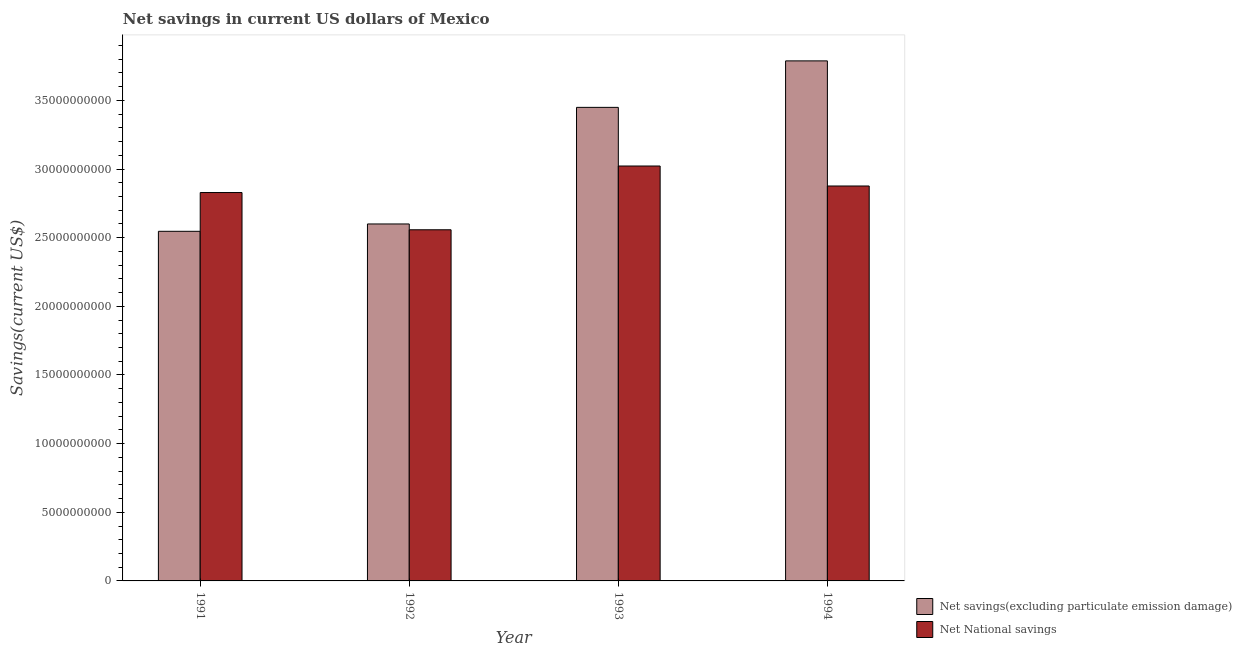How many different coloured bars are there?
Keep it short and to the point. 2. How many groups of bars are there?
Your response must be concise. 4. Are the number of bars per tick equal to the number of legend labels?
Ensure brevity in your answer.  Yes. Are the number of bars on each tick of the X-axis equal?
Ensure brevity in your answer.  Yes. How many bars are there on the 1st tick from the right?
Your answer should be very brief. 2. What is the label of the 2nd group of bars from the left?
Offer a very short reply. 1992. What is the net national savings in 1993?
Ensure brevity in your answer.  3.02e+1. Across all years, what is the maximum net national savings?
Give a very brief answer. 3.02e+1. Across all years, what is the minimum net national savings?
Offer a terse response. 2.56e+1. In which year was the net savings(excluding particulate emission damage) minimum?
Your answer should be compact. 1991. What is the total net national savings in the graph?
Keep it short and to the point. 1.13e+11. What is the difference between the net national savings in 1991 and that in 1992?
Your answer should be compact. 2.71e+09. What is the difference between the net national savings in 1991 and the net savings(excluding particulate emission damage) in 1993?
Offer a very short reply. -1.93e+09. What is the average net savings(excluding particulate emission damage) per year?
Your response must be concise. 3.10e+1. What is the ratio of the net national savings in 1992 to that in 1994?
Provide a succinct answer. 0.89. Is the net savings(excluding particulate emission damage) in 1991 less than that in 1993?
Give a very brief answer. Yes. Is the difference between the net savings(excluding particulate emission damage) in 1991 and 1993 greater than the difference between the net national savings in 1991 and 1993?
Make the answer very short. No. What is the difference between the highest and the second highest net savings(excluding particulate emission damage)?
Ensure brevity in your answer.  3.39e+09. What is the difference between the highest and the lowest net savings(excluding particulate emission damage)?
Provide a short and direct response. 1.24e+1. Is the sum of the net savings(excluding particulate emission damage) in 1991 and 1993 greater than the maximum net national savings across all years?
Keep it short and to the point. Yes. What does the 1st bar from the left in 1993 represents?
Offer a very short reply. Net savings(excluding particulate emission damage). What does the 2nd bar from the right in 1993 represents?
Ensure brevity in your answer.  Net savings(excluding particulate emission damage). What is the difference between two consecutive major ticks on the Y-axis?
Your answer should be compact. 5.00e+09. Are the values on the major ticks of Y-axis written in scientific E-notation?
Offer a terse response. No. Does the graph contain any zero values?
Provide a succinct answer. No. Does the graph contain grids?
Ensure brevity in your answer.  No. Where does the legend appear in the graph?
Provide a short and direct response. Bottom right. How are the legend labels stacked?
Keep it short and to the point. Vertical. What is the title of the graph?
Provide a succinct answer. Net savings in current US dollars of Mexico. Does "Constant 2005 US$" appear as one of the legend labels in the graph?
Your answer should be compact. No. What is the label or title of the X-axis?
Make the answer very short. Year. What is the label or title of the Y-axis?
Offer a very short reply. Savings(current US$). What is the Savings(current US$) in Net savings(excluding particulate emission damage) in 1991?
Give a very brief answer. 2.55e+1. What is the Savings(current US$) in Net National savings in 1991?
Keep it short and to the point. 2.83e+1. What is the Savings(current US$) in Net savings(excluding particulate emission damage) in 1992?
Your answer should be very brief. 2.60e+1. What is the Savings(current US$) of Net National savings in 1992?
Offer a very short reply. 2.56e+1. What is the Savings(current US$) in Net savings(excluding particulate emission damage) in 1993?
Offer a terse response. 3.45e+1. What is the Savings(current US$) in Net National savings in 1993?
Provide a succinct answer. 3.02e+1. What is the Savings(current US$) in Net savings(excluding particulate emission damage) in 1994?
Offer a very short reply. 3.79e+1. What is the Savings(current US$) of Net National savings in 1994?
Make the answer very short. 2.88e+1. Across all years, what is the maximum Savings(current US$) in Net savings(excluding particulate emission damage)?
Make the answer very short. 3.79e+1. Across all years, what is the maximum Savings(current US$) in Net National savings?
Offer a very short reply. 3.02e+1. Across all years, what is the minimum Savings(current US$) of Net savings(excluding particulate emission damage)?
Provide a short and direct response. 2.55e+1. Across all years, what is the minimum Savings(current US$) of Net National savings?
Offer a very short reply. 2.56e+1. What is the total Savings(current US$) in Net savings(excluding particulate emission damage) in the graph?
Offer a very short reply. 1.24e+11. What is the total Savings(current US$) in Net National savings in the graph?
Your answer should be very brief. 1.13e+11. What is the difference between the Savings(current US$) in Net savings(excluding particulate emission damage) in 1991 and that in 1992?
Your answer should be compact. -5.34e+08. What is the difference between the Savings(current US$) of Net National savings in 1991 and that in 1992?
Your answer should be compact. 2.71e+09. What is the difference between the Savings(current US$) in Net savings(excluding particulate emission damage) in 1991 and that in 1993?
Your response must be concise. -9.03e+09. What is the difference between the Savings(current US$) in Net National savings in 1991 and that in 1993?
Provide a short and direct response. -1.93e+09. What is the difference between the Savings(current US$) of Net savings(excluding particulate emission damage) in 1991 and that in 1994?
Provide a succinct answer. -1.24e+1. What is the difference between the Savings(current US$) in Net National savings in 1991 and that in 1994?
Your answer should be very brief. -4.77e+08. What is the difference between the Savings(current US$) in Net savings(excluding particulate emission damage) in 1992 and that in 1993?
Offer a terse response. -8.49e+09. What is the difference between the Savings(current US$) in Net National savings in 1992 and that in 1993?
Make the answer very short. -4.65e+09. What is the difference between the Savings(current US$) in Net savings(excluding particulate emission damage) in 1992 and that in 1994?
Give a very brief answer. -1.19e+1. What is the difference between the Savings(current US$) of Net National savings in 1992 and that in 1994?
Make the answer very short. -3.19e+09. What is the difference between the Savings(current US$) in Net savings(excluding particulate emission damage) in 1993 and that in 1994?
Ensure brevity in your answer.  -3.39e+09. What is the difference between the Savings(current US$) in Net National savings in 1993 and that in 1994?
Your answer should be compact. 1.46e+09. What is the difference between the Savings(current US$) in Net savings(excluding particulate emission damage) in 1991 and the Savings(current US$) in Net National savings in 1992?
Your answer should be very brief. -1.11e+08. What is the difference between the Savings(current US$) in Net savings(excluding particulate emission damage) in 1991 and the Savings(current US$) in Net National savings in 1993?
Make the answer very short. -4.76e+09. What is the difference between the Savings(current US$) in Net savings(excluding particulate emission damage) in 1991 and the Savings(current US$) in Net National savings in 1994?
Your answer should be very brief. -3.30e+09. What is the difference between the Savings(current US$) of Net savings(excluding particulate emission damage) in 1992 and the Savings(current US$) of Net National savings in 1993?
Keep it short and to the point. -4.22e+09. What is the difference between the Savings(current US$) in Net savings(excluding particulate emission damage) in 1992 and the Savings(current US$) in Net National savings in 1994?
Provide a succinct answer. -2.77e+09. What is the difference between the Savings(current US$) in Net savings(excluding particulate emission damage) in 1993 and the Savings(current US$) in Net National savings in 1994?
Give a very brief answer. 5.73e+09. What is the average Savings(current US$) in Net savings(excluding particulate emission damage) per year?
Give a very brief answer. 3.10e+1. What is the average Savings(current US$) in Net National savings per year?
Your response must be concise. 2.82e+1. In the year 1991, what is the difference between the Savings(current US$) in Net savings(excluding particulate emission damage) and Savings(current US$) in Net National savings?
Your response must be concise. -2.82e+09. In the year 1992, what is the difference between the Savings(current US$) in Net savings(excluding particulate emission damage) and Savings(current US$) in Net National savings?
Your response must be concise. 4.23e+08. In the year 1993, what is the difference between the Savings(current US$) in Net savings(excluding particulate emission damage) and Savings(current US$) in Net National savings?
Provide a succinct answer. 4.27e+09. In the year 1994, what is the difference between the Savings(current US$) in Net savings(excluding particulate emission damage) and Savings(current US$) in Net National savings?
Offer a terse response. 9.11e+09. What is the ratio of the Savings(current US$) in Net savings(excluding particulate emission damage) in 1991 to that in 1992?
Offer a very short reply. 0.98. What is the ratio of the Savings(current US$) of Net National savings in 1991 to that in 1992?
Your response must be concise. 1.11. What is the ratio of the Savings(current US$) in Net savings(excluding particulate emission damage) in 1991 to that in 1993?
Your answer should be compact. 0.74. What is the ratio of the Savings(current US$) in Net National savings in 1991 to that in 1993?
Offer a terse response. 0.94. What is the ratio of the Savings(current US$) of Net savings(excluding particulate emission damage) in 1991 to that in 1994?
Provide a short and direct response. 0.67. What is the ratio of the Savings(current US$) of Net National savings in 1991 to that in 1994?
Give a very brief answer. 0.98. What is the ratio of the Savings(current US$) in Net savings(excluding particulate emission damage) in 1992 to that in 1993?
Make the answer very short. 0.75. What is the ratio of the Savings(current US$) of Net National savings in 1992 to that in 1993?
Offer a terse response. 0.85. What is the ratio of the Savings(current US$) of Net savings(excluding particulate emission damage) in 1992 to that in 1994?
Make the answer very short. 0.69. What is the ratio of the Savings(current US$) in Net National savings in 1992 to that in 1994?
Ensure brevity in your answer.  0.89. What is the ratio of the Savings(current US$) of Net savings(excluding particulate emission damage) in 1993 to that in 1994?
Provide a short and direct response. 0.91. What is the ratio of the Savings(current US$) of Net National savings in 1993 to that in 1994?
Your response must be concise. 1.05. What is the difference between the highest and the second highest Savings(current US$) in Net savings(excluding particulate emission damage)?
Give a very brief answer. 3.39e+09. What is the difference between the highest and the second highest Savings(current US$) in Net National savings?
Your response must be concise. 1.46e+09. What is the difference between the highest and the lowest Savings(current US$) of Net savings(excluding particulate emission damage)?
Provide a short and direct response. 1.24e+1. What is the difference between the highest and the lowest Savings(current US$) of Net National savings?
Your answer should be compact. 4.65e+09. 